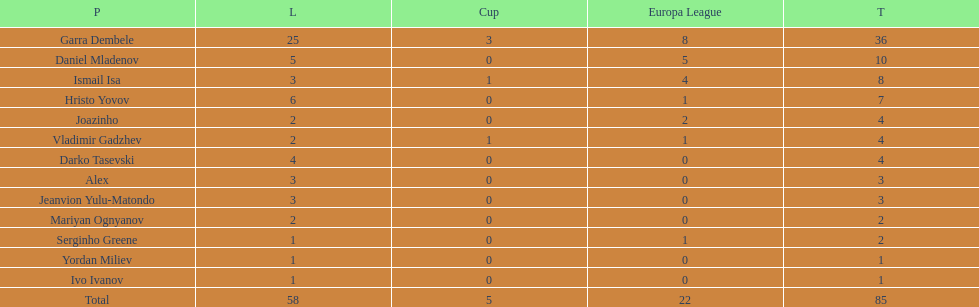Which is the only player from germany? Jeanvion Yulu-Matondo. 